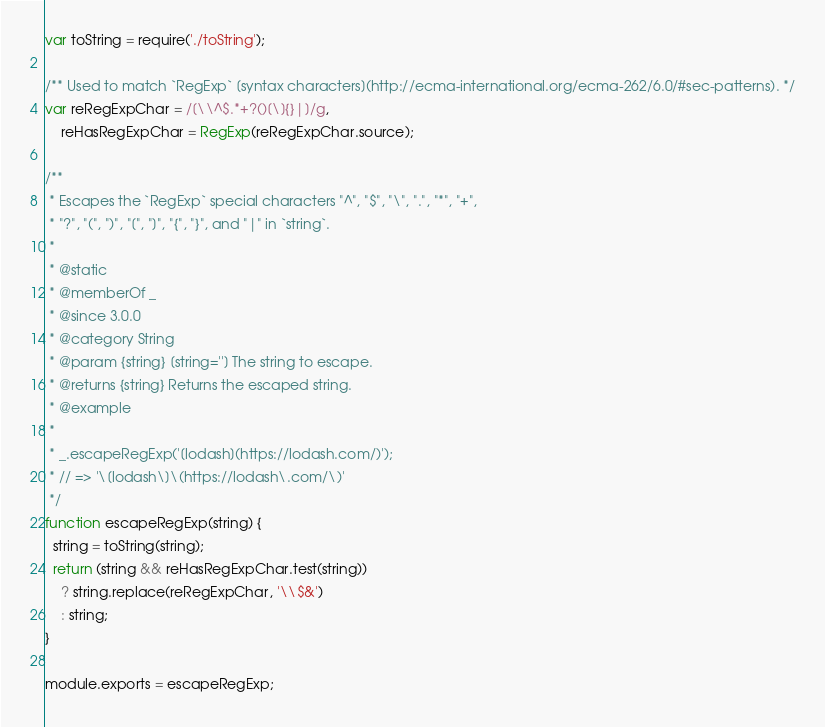<code> <loc_0><loc_0><loc_500><loc_500><_JavaScript_>var toString = require('./toString');

/** Used to match `RegExp` [syntax characters](http://ecma-international.org/ecma-262/6.0/#sec-patterns). */
var reRegExpChar = /[\\^$.*+?()[\]{}|]/g,
    reHasRegExpChar = RegExp(reRegExpChar.source);

/**
 * Escapes the `RegExp` special characters "^", "$", "\", ".", "*", "+",
 * "?", "(", ")", "[", "]", "{", "}", and "|" in `string`.
 *
 * @static
 * @memberOf _
 * @since 3.0.0
 * @category String
 * @param {string} [string=''] The string to escape.
 * @returns {string} Returns the escaped string.
 * @example
 *
 * _.escapeRegExp('[lodash](https://lodash.com/)');
 * // => '\[lodash\]\(https://lodash\.com/\)'
 */
function escapeRegExp(string) {
  string = toString(string);
  return (string && reHasRegExpChar.test(string))
    ? string.replace(reRegExpChar, '\\$&')
    : string;
}

module.exports = escapeRegExp;
</code> 